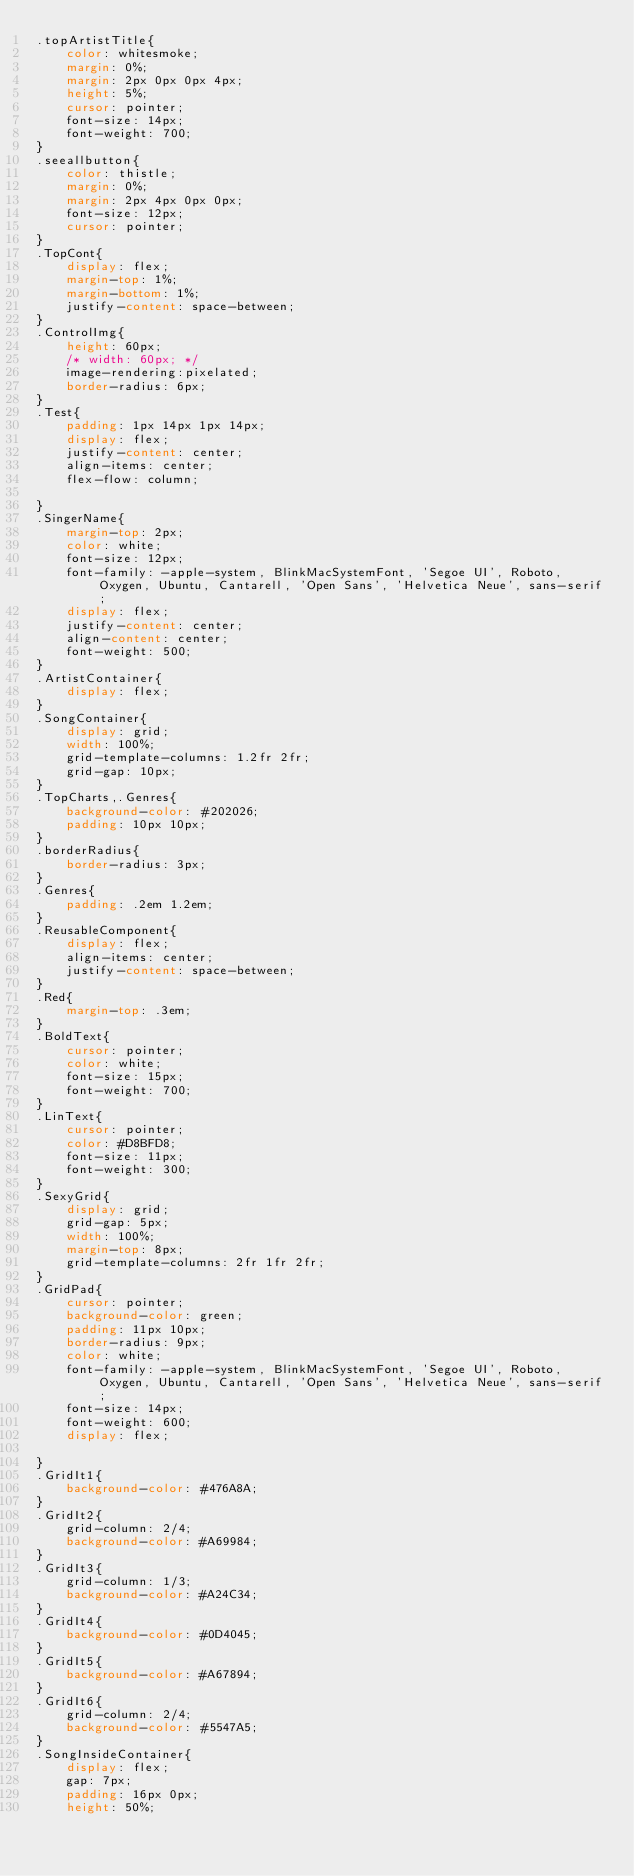<code> <loc_0><loc_0><loc_500><loc_500><_CSS_>.topArtistTitle{
    color: whitesmoke;
    margin: 0%;
    margin: 2px 0px 0px 4px;
    height: 5%;
    cursor: pointer;
    font-size: 14px;
    font-weight: 700;
}
.seeallbutton{
    color: thistle;
    margin: 0%;
    margin: 2px 4px 0px 0px;
    font-size: 12px;
    cursor: pointer;
}
.TopCont{
    display: flex;
    margin-top: 1%;
    margin-bottom: 1%;
    justify-content: space-between;
}
.ControlImg{
    height: 60px;
    /* width: 60px; */
    image-rendering:pixelated;
    border-radius: 6px;
}
.Test{
    padding: 1px 14px 1px 14px;
    display: flex;
    justify-content: center;
    align-items: center;
    flex-flow: column;

}
.SingerName{
    margin-top: 2px;
    color: white;
    font-size: 12px;
    font-family: -apple-system, BlinkMacSystemFont, 'Segoe UI', Roboto, Oxygen, Ubuntu, Cantarell, 'Open Sans', 'Helvetica Neue', sans-serif;
    display: flex;
    justify-content: center;
    align-content: center;
    font-weight: 500;
}
.ArtistContainer{
    display: flex;
}
.SongContainer{
    display: grid;
    width: 100%;
    grid-template-columns: 1.2fr 2fr;
    grid-gap: 10px;
}
.TopCharts,.Genres{
    background-color: #202026;
    padding: 10px 10px;
}
.borderRadius{
    border-radius: 3px;
}
.Genres{
    padding: .2em 1.2em;
}
.ReusableComponent{
    display: flex;
    align-items: center;
    justify-content: space-between;
}
.Red{
    margin-top: .3em;
}
.BoldText{
    cursor: pointer;
    color: white;
    font-size: 15px;
    font-weight: 700;
}
.LinText{
    cursor: pointer;
    color: #D8BFD8;
    font-size: 11px;
    font-weight: 300;
}
.SexyGrid{
    display: grid;
    grid-gap: 5px;
    width: 100%;
    margin-top: 8px;
    grid-template-columns: 2fr 1fr 2fr;
}
.GridPad{
    cursor: pointer;
    background-color: green;
    padding: 11px 10px;
    border-radius: 9px;
    color: white;
    font-family: -apple-system, BlinkMacSystemFont, 'Segoe UI', Roboto, Oxygen, Ubuntu, Cantarell, 'Open Sans', 'Helvetica Neue', sans-serif;
    font-size: 14px;
    font-weight: 600;
    display: flex;
    
}
.GridIt1{
    background-color: #476A8A;
}
.GridIt2{
    grid-column: 2/4;
    background-color: #A69984;
}
.GridIt3{
    grid-column: 1/3;
    background-color: #A24C34;
}
.GridIt4{
    background-color: #0D4045;
}
.GridIt5{
    background-color: #A67894;
}
.GridIt6{
    grid-column: 2/4;
    background-color: #5547A5;
}
.SongInsideContainer{
    display: flex;
    gap: 7px;
    padding: 16px 0px;
    height: 50%;</code> 